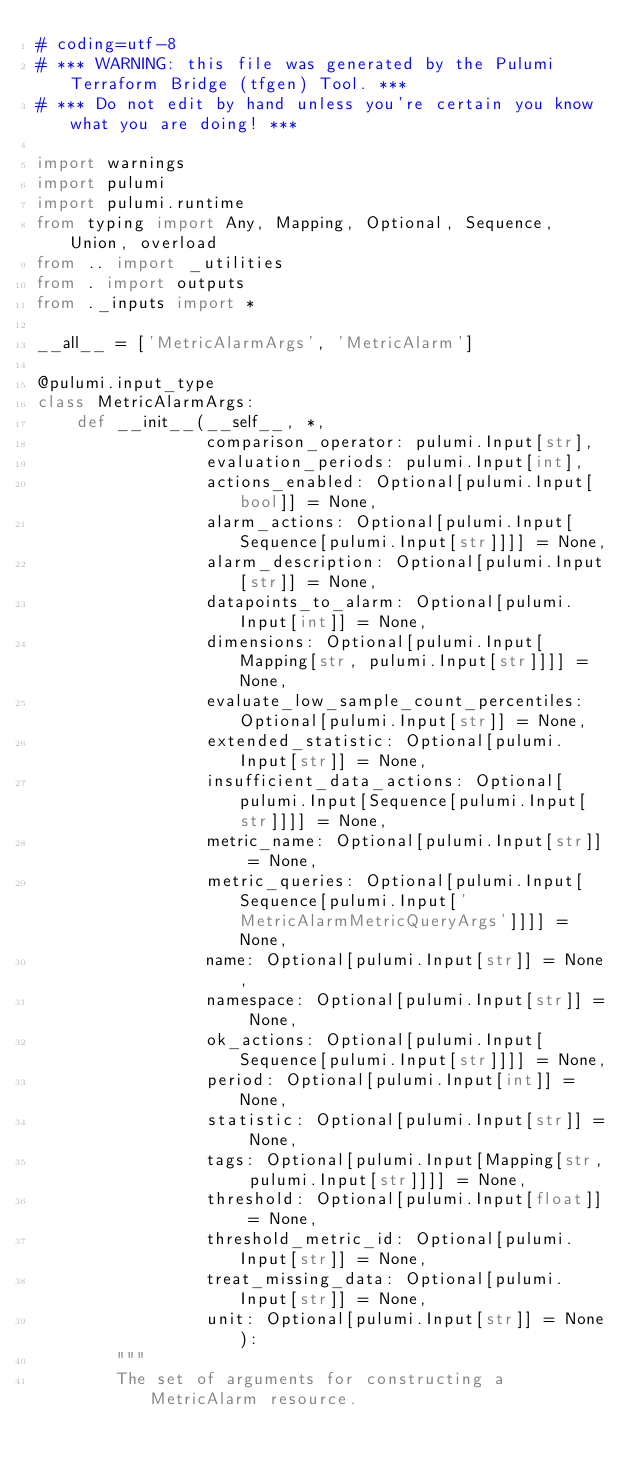<code> <loc_0><loc_0><loc_500><loc_500><_Python_># coding=utf-8
# *** WARNING: this file was generated by the Pulumi Terraform Bridge (tfgen) Tool. ***
# *** Do not edit by hand unless you're certain you know what you are doing! ***

import warnings
import pulumi
import pulumi.runtime
from typing import Any, Mapping, Optional, Sequence, Union, overload
from .. import _utilities
from . import outputs
from ._inputs import *

__all__ = ['MetricAlarmArgs', 'MetricAlarm']

@pulumi.input_type
class MetricAlarmArgs:
    def __init__(__self__, *,
                 comparison_operator: pulumi.Input[str],
                 evaluation_periods: pulumi.Input[int],
                 actions_enabled: Optional[pulumi.Input[bool]] = None,
                 alarm_actions: Optional[pulumi.Input[Sequence[pulumi.Input[str]]]] = None,
                 alarm_description: Optional[pulumi.Input[str]] = None,
                 datapoints_to_alarm: Optional[pulumi.Input[int]] = None,
                 dimensions: Optional[pulumi.Input[Mapping[str, pulumi.Input[str]]]] = None,
                 evaluate_low_sample_count_percentiles: Optional[pulumi.Input[str]] = None,
                 extended_statistic: Optional[pulumi.Input[str]] = None,
                 insufficient_data_actions: Optional[pulumi.Input[Sequence[pulumi.Input[str]]]] = None,
                 metric_name: Optional[pulumi.Input[str]] = None,
                 metric_queries: Optional[pulumi.Input[Sequence[pulumi.Input['MetricAlarmMetricQueryArgs']]]] = None,
                 name: Optional[pulumi.Input[str]] = None,
                 namespace: Optional[pulumi.Input[str]] = None,
                 ok_actions: Optional[pulumi.Input[Sequence[pulumi.Input[str]]]] = None,
                 period: Optional[pulumi.Input[int]] = None,
                 statistic: Optional[pulumi.Input[str]] = None,
                 tags: Optional[pulumi.Input[Mapping[str, pulumi.Input[str]]]] = None,
                 threshold: Optional[pulumi.Input[float]] = None,
                 threshold_metric_id: Optional[pulumi.Input[str]] = None,
                 treat_missing_data: Optional[pulumi.Input[str]] = None,
                 unit: Optional[pulumi.Input[str]] = None):
        """
        The set of arguments for constructing a MetricAlarm resource.</code> 